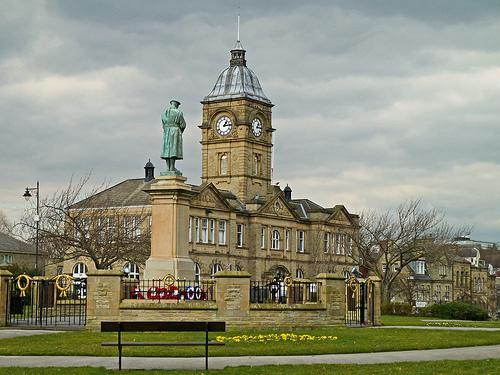Question: how many tall lamp posts are in the picture?
Choices:
A. Two.
B. One.
C. Three.
D. Four.
Answer with the letter. Answer: B Question: what is on a pillar?
Choices:
A. The statue.
B. Cables.
C. A fountain.
D. An animal.
Answer with the letter. Answer: A Question: what color are the flowers on the ground?
Choices:
A. Yellow.
B. Red.
C. Blue.
D. Orange.
Answer with the letter. Answer: A Question: what is in the sky?
Choices:
A. Birds.
B. Lightening.
C. Kites.
D. Clouds.
Answer with the letter. Answer: D 